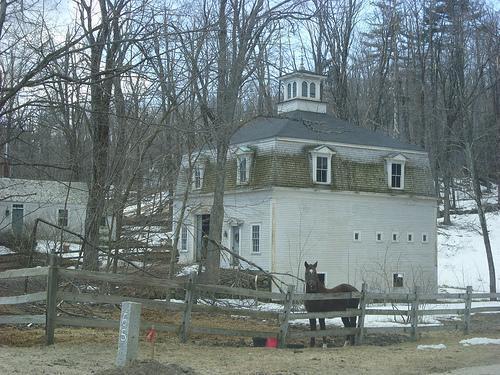How many horses are shown?
Give a very brief answer. 1. 